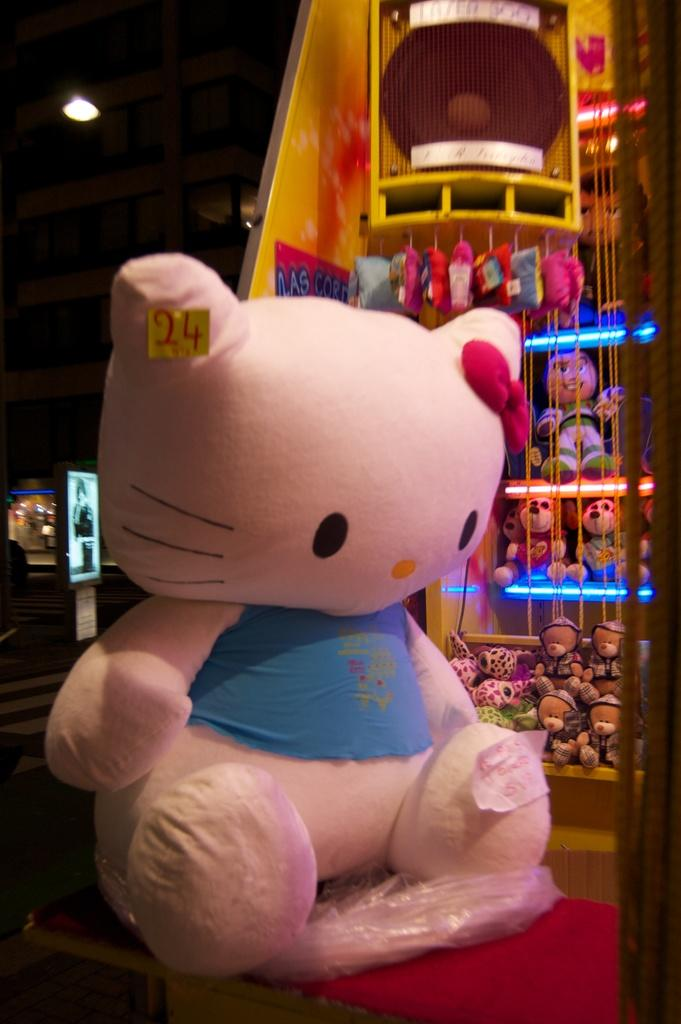What type of objects can be seen in the image? There are soft toys in the image. Can you describe one of the soft toys? One of the soft toys is pink in color. What can be seen in the background of the image? There are lights and other objects visible in the background of the image. How would you describe the overall lighting in the image? The background of the image is dark. Can you tell me how many times the person in the image coughed before taking the photo? There is no person present in the image, and therefore no coughing can be observed. Is there any food visible in the image? No, there is no food visible in the image. 